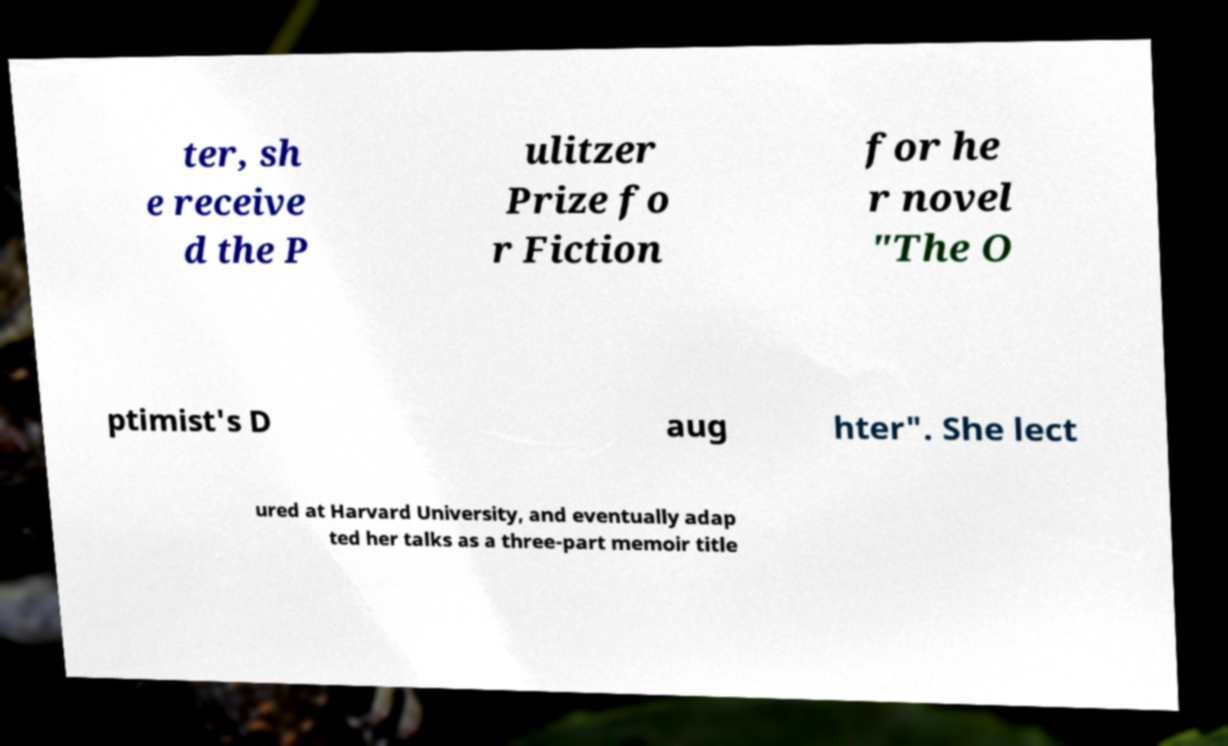Can you accurately transcribe the text from the provided image for me? ter, sh e receive d the P ulitzer Prize fo r Fiction for he r novel "The O ptimist's D aug hter". She lect ured at Harvard University, and eventually adap ted her talks as a three-part memoir title 